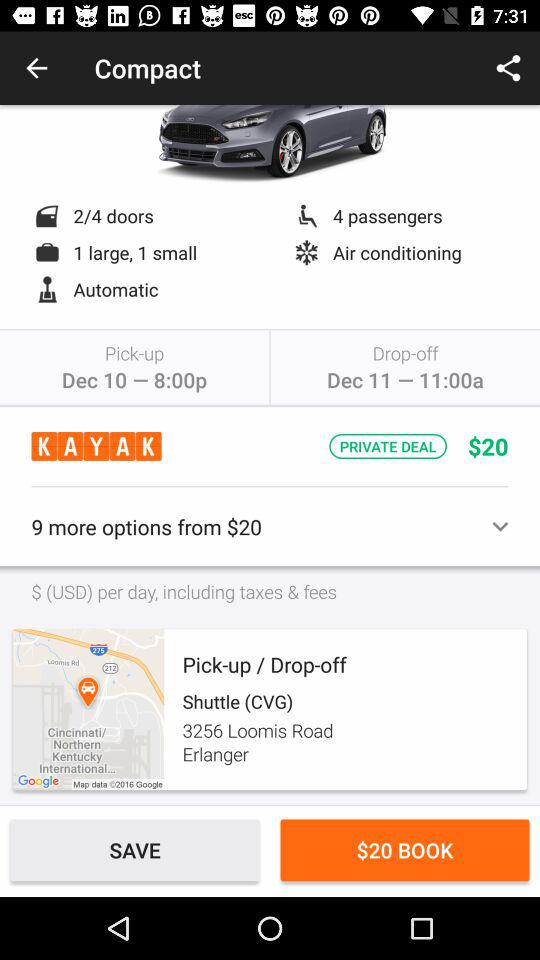How many more options are available for $20? There are 9 more options available for $20. 